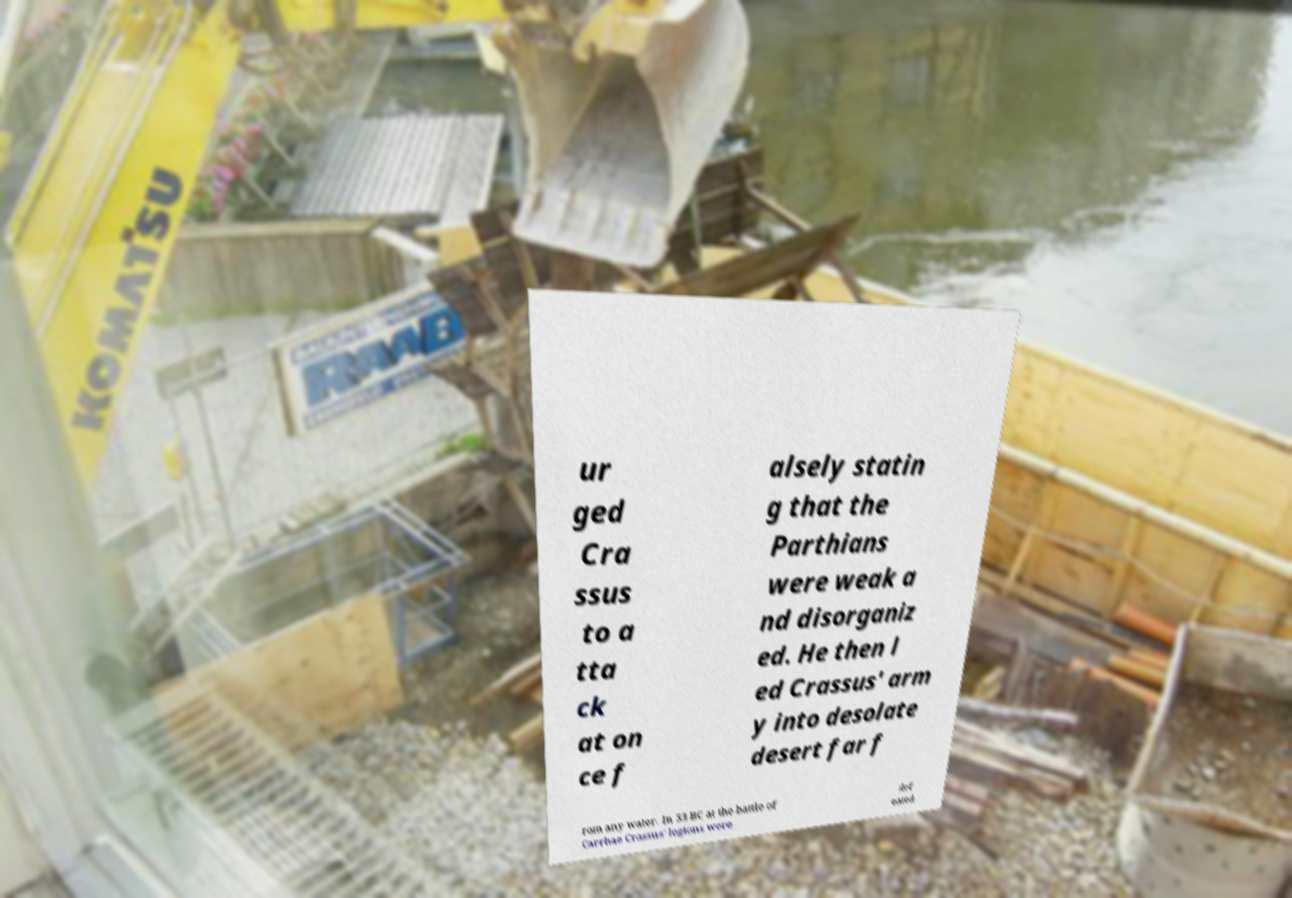I need the written content from this picture converted into text. Can you do that? ur ged Cra ssus to a tta ck at on ce f alsely statin g that the Parthians were weak a nd disorganiz ed. He then l ed Crassus' arm y into desolate desert far f rom any water. In 53 BC at the battle of Carrhae Crassus' legions were def eated 